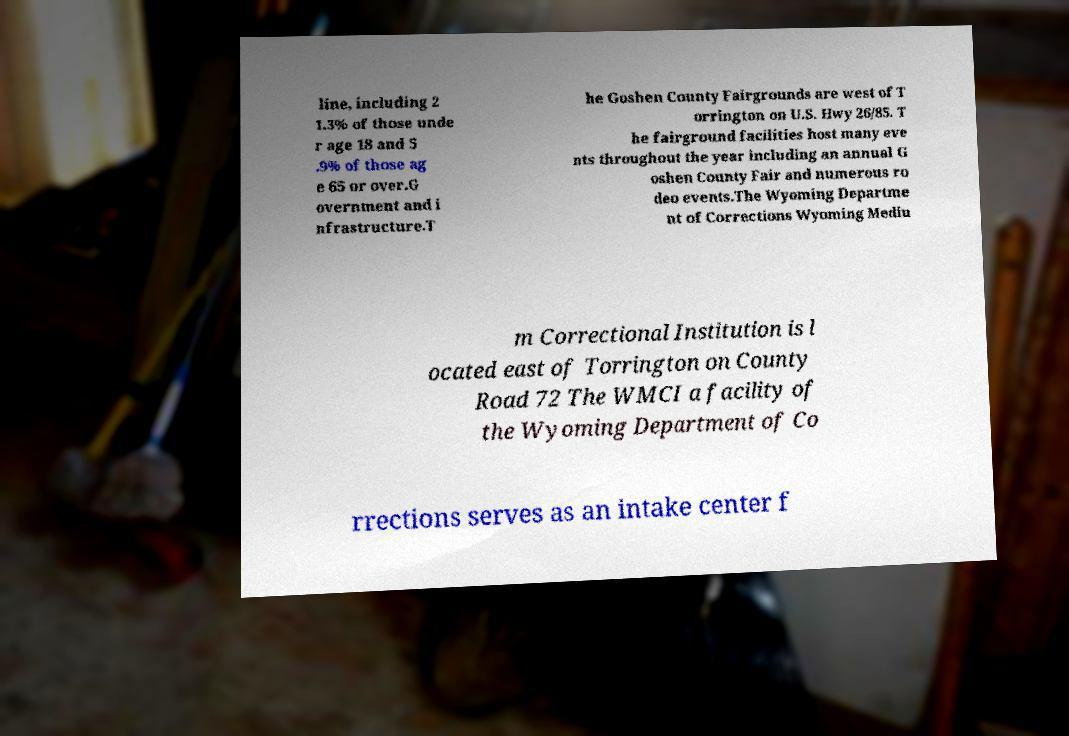Could you assist in decoding the text presented in this image and type it out clearly? line, including 2 1.3% of those unde r age 18 and 5 .9% of those ag e 65 or over.G overnment and i nfrastructure.T he Goshen County Fairgrounds are west of T orrington on U.S. Hwy 26/85. T he fairground facilities host many eve nts throughout the year including an annual G oshen County Fair and numerous ro deo events.The Wyoming Departme nt of Corrections Wyoming Mediu m Correctional Institution is l ocated east of Torrington on County Road 72 The WMCI a facility of the Wyoming Department of Co rrections serves as an intake center f 